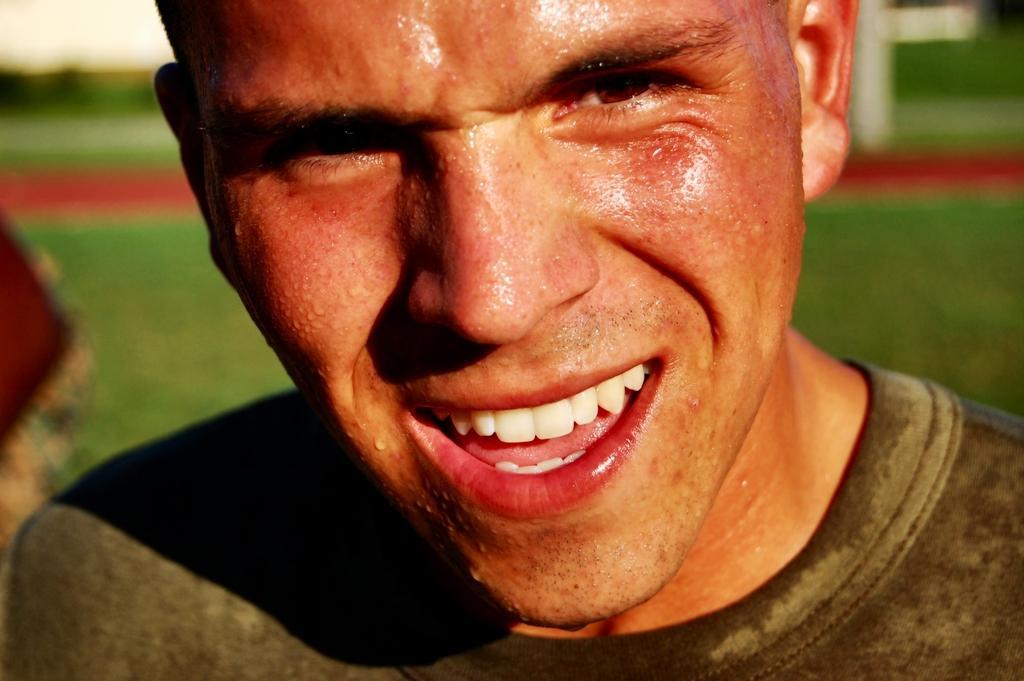In one or two sentences, can you explain what this image depicts? There is a man in the center of the image, it seems like grassland in the background area. 